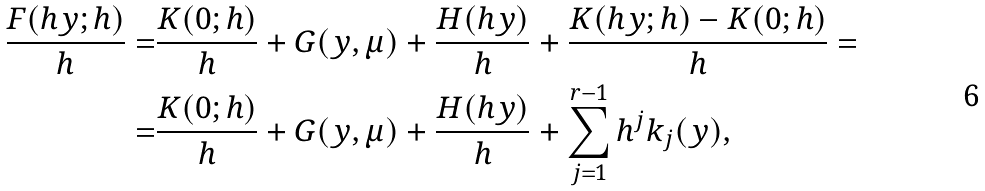<formula> <loc_0><loc_0><loc_500><loc_500>\frac { F ( h y ; h ) } { h } = & \frac { K ( 0 ; h ) } { h } + G ( y , \mu ) + \frac { H ( h y ) } { h } + \frac { K ( h y ; h ) - K ( 0 ; h ) } { h } = \\ = & \frac { K ( 0 ; h ) } { h } + G ( y , \mu ) + \frac { H ( h y ) } { h } + \sum _ { j = 1 } ^ { r - 1 } h ^ { j } k _ { j } ( y ) ,</formula> 